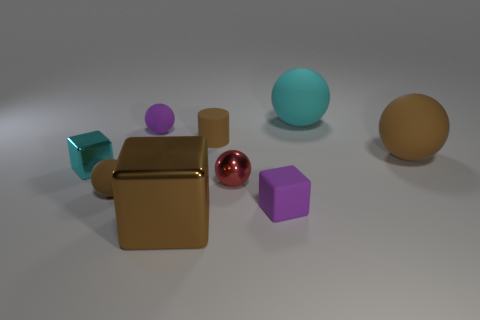Subtract all small purple spheres. How many spheres are left? 4 Subtract all yellow spheres. Subtract all yellow blocks. How many spheres are left? 5 Add 1 brown cylinders. How many objects exist? 10 Subtract all cylinders. How many objects are left? 8 Subtract 0 blue spheres. How many objects are left? 9 Subtract all tiny cyan metallic cubes. Subtract all small red metallic cubes. How many objects are left? 8 Add 6 large brown metallic things. How many large brown metallic things are left? 7 Add 3 brown shiny cubes. How many brown shiny cubes exist? 4 